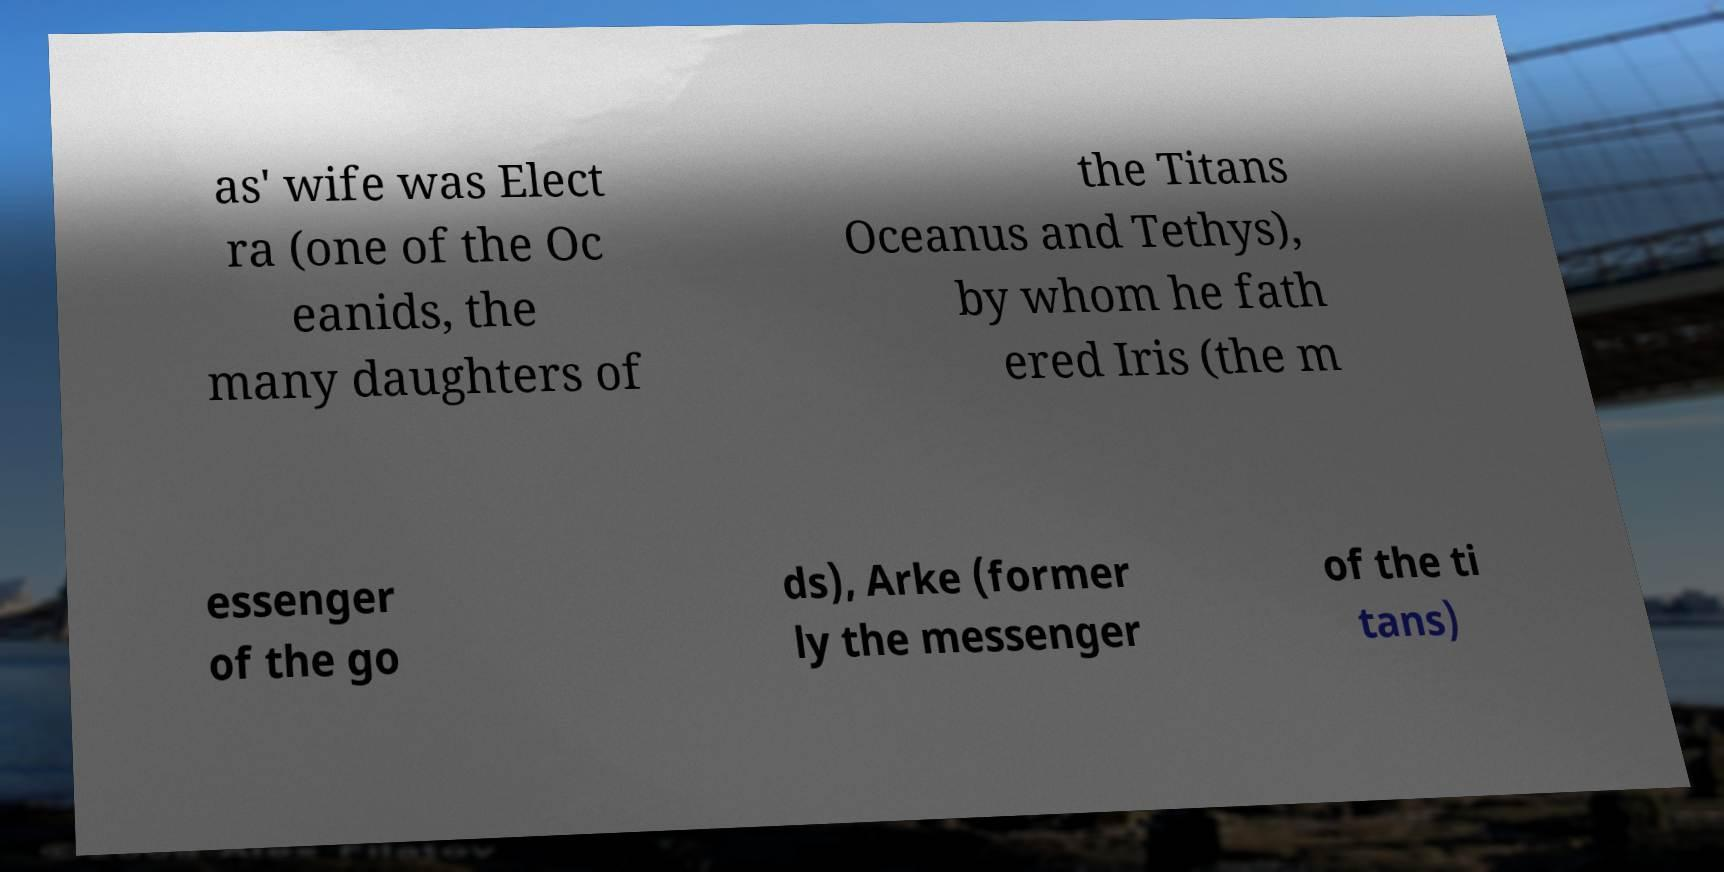Please identify and transcribe the text found in this image. as' wife was Elect ra (one of the Oc eanids, the many daughters of the Titans Oceanus and Tethys), by whom he fath ered Iris (the m essenger of the go ds), Arke (former ly the messenger of the ti tans) 